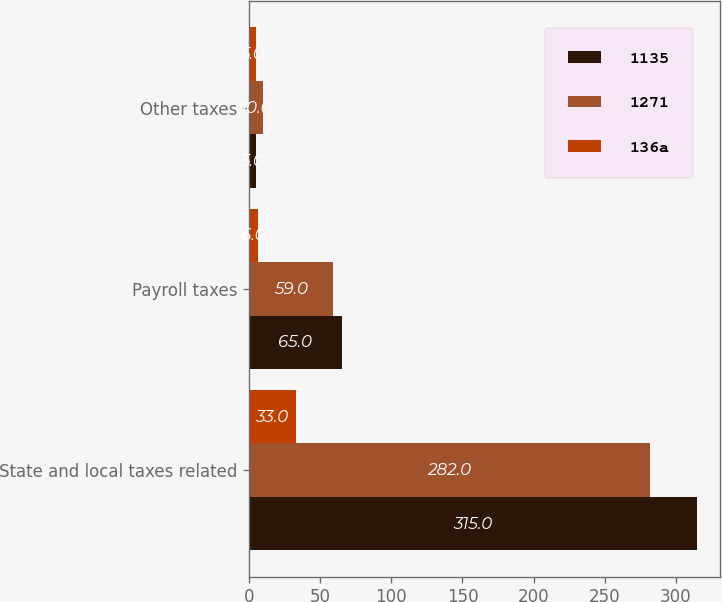Convert chart to OTSL. <chart><loc_0><loc_0><loc_500><loc_500><stacked_bar_chart><ecel><fcel>State and local taxes related<fcel>Payroll taxes<fcel>Other taxes<nl><fcel>1135<fcel>315<fcel>65<fcel>5<nl><fcel>1271<fcel>282<fcel>59<fcel>10<nl><fcel>136a<fcel>33<fcel>6<fcel>5<nl></chart> 